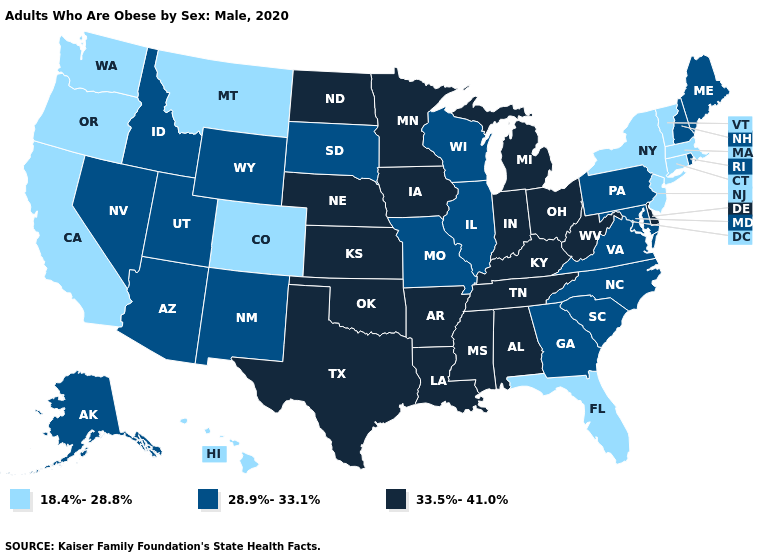What is the value of Louisiana?
Quick response, please. 33.5%-41.0%. What is the lowest value in the USA?
Be succinct. 18.4%-28.8%. Name the states that have a value in the range 28.9%-33.1%?
Write a very short answer. Alaska, Arizona, Georgia, Idaho, Illinois, Maine, Maryland, Missouri, Nevada, New Hampshire, New Mexico, North Carolina, Pennsylvania, Rhode Island, South Carolina, South Dakota, Utah, Virginia, Wisconsin, Wyoming. Does the map have missing data?
Short answer required. No. What is the lowest value in states that border Mississippi?
Quick response, please. 33.5%-41.0%. Does South Dakota have the highest value in the MidWest?
Keep it brief. No. Is the legend a continuous bar?
Short answer required. No. Name the states that have a value in the range 28.9%-33.1%?
Short answer required. Alaska, Arizona, Georgia, Idaho, Illinois, Maine, Maryland, Missouri, Nevada, New Hampshire, New Mexico, North Carolina, Pennsylvania, Rhode Island, South Carolina, South Dakota, Utah, Virginia, Wisconsin, Wyoming. Name the states that have a value in the range 18.4%-28.8%?
Be succinct. California, Colorado, Connecticut, Florida, Hawaii, Massachusetts, Montana, New Jersey, New York, Oregon, Vermont, Washington. Does Maryland have the lowest value in the USA?
Give a very brief answer. No. Does the map have missing data?
Answer briefly. No. Which states have the lowest value in the South?
Be succinct. Florida. Which states hav the highest value in the MidWest?
Write a very short answer. Indiana, Iowa, Kansas, Michigan, Minnesota, Nebraska, North Dakota, Ohio. Does the first symbol in the legend represent the smallest category?
Concise answer only. Yes. Does Rhode Island have a higher value than Michigan?
Be succinct. No. 